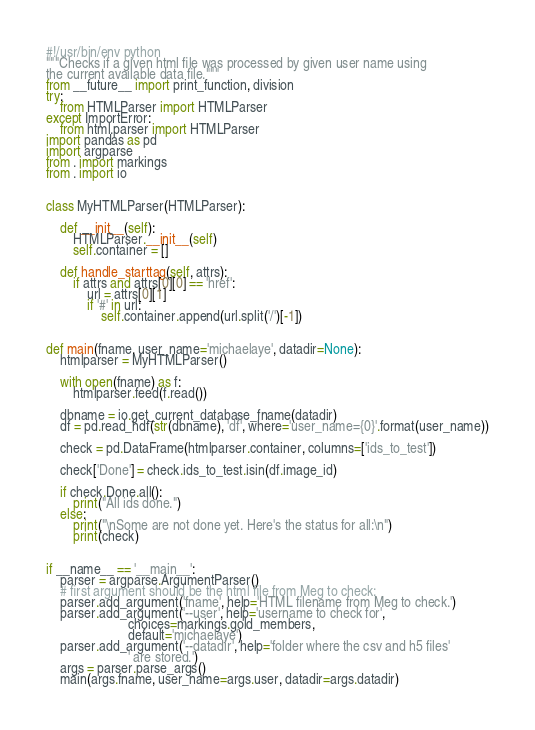Convert code to text. <code><loc_0><loc_0><loc_500><loc_500><_Python_>#!/usr/bin/env python
"""Checks if a given html file was processed by given user name using
the current available data file."""
from __future__ import print_function, division
try:
    from HTMLParser import HTMLParser
except ImportError:
    from html.parser import HTMLParser
import pandas as pd
import argparse
from . import markings
from . import io


class MyHTMLParser(HTMLParser):

    def __init__(self):
        HTMLParser.__init__(self)
        self.container = []

    def handle_starttag(self, attrs):
        if attrs and attrs[0][0] == 'href':
            url = attrs[0][1]
            if '#' in url:
                self.container.append(url.split('/')[-1])


def main(fname, user_name='michaelaye', datadir=None):
    htmlparser = MyHTMLParser()

    with open(fname) as f:
        htmlparser.feed(f.read())

    dbname = io.get_current_database_fname(datadir)
    df = pd.read_hdf(str(dbname), 'df', where='user_name={0}'.format(user_name))

    check = pd.DataFrame(htmlparser.container, columns=['ids_to_test'])

    check['Done'] = check.ids_to_test.isin(df.image_id)

    if check.Done.all():
        print("All ids done.")
    else:
        print("\nSome are not done yet. Here's the status for all:\n")
        print(check)


if __name__ == '__main__':
    parser = argparse.ArgumentParser()
    # first argument should be the html file from Meg to check:
    parser.add_argument('fname', help='HTML filename from Meg to check.')
    parser.add_argument('--user', help='username to check for',
                        choices=markings.gold_members,
                        default='michaelaye')
    parser.add_argument('--datadir', help='folder where the csv and h5 files'
                        ' are stored.')
    args = parser.parse_args()
    main(args.fname, user_name=args.user, datadir=args.datadir)
</code> 